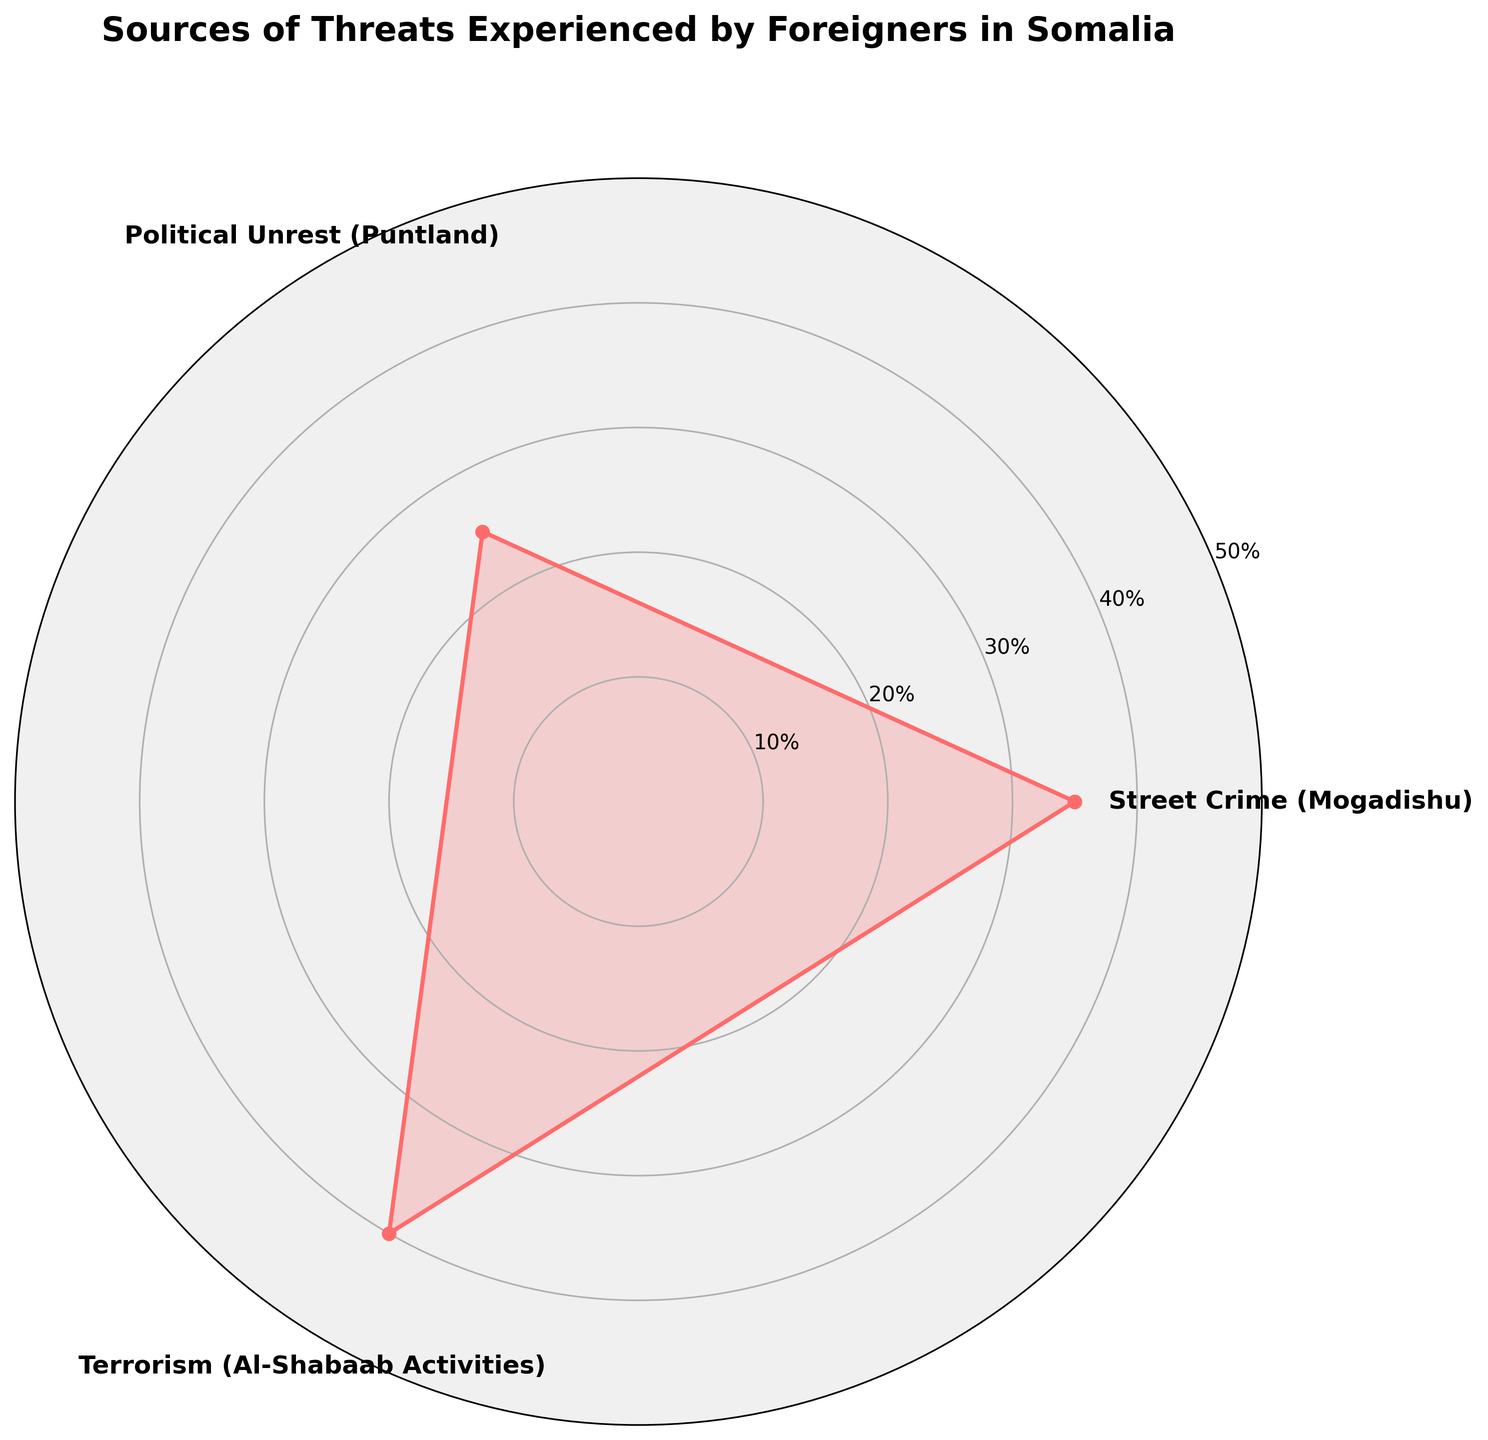what are the sources of threats mentioned in the rose chart? The sources of threats are labeled as categories in the chart. By looking at the labels around the chart, you can identify these sources.
Answer: Street Crime (Mogadishu), Political Unrest (Puntland), Terrorism (Al-Shabaab Activities) which source has the highest proportion of threats? By identifying the highest value on the radial axis and referring to its corresponding category, you can determine the source with the highest threat proportion.
Answer: Terrorism (Al-Shabaab Activities) what is the proportion of threats due to street crime? Find the label "Street Crime (Mogadishu)" on the chart and look at the radial level it reaches to find the percentage.
Answer: 35% how much higher is the proportion of threats from terrorism compared to political unrest? Subtract the proportion of political unrest from the proportion of terrorism to find the difference.
Answer: 40% - 25% = 15% which category has the lowest proportion of threats? Identify the category with the smallest radial value.
Answer: Political Unrest (Puntland) what is the average proportion of threats across all sources? Sum up all the proportions and divide by the number of categories to find the average.
Answer: (35% + 25% + 40%) / 3 = 33.33% how does the proportion of threats due to street crime compare with political unrest? Compare the proportions of street crime and political unrest by identifying their values on the radial axis.
Answer: Street crime is higher than political unrest what visual attributes can help you easily identify the proportions? Look at the length of the filled sections from the center to the edge, along with the labels and radial tick marks.
Answer: Length of filled sections, labels, radial tick marks what percentage does the category with the highest threat constitute? Find the highest radial value and read the corresponding percentage.
Answer: 40% how can you describe the overall distribution of threats among the categories? Observe the relative magnitudes of the filled sections for each category to summarize the distribution.
Answer: There is a varied distribution of threats with Terrorism (Al-Shabaab Activities) being the highest, followed by Street Crime (Mogadishu), and Political Unrest (Puntland) being the lowest 